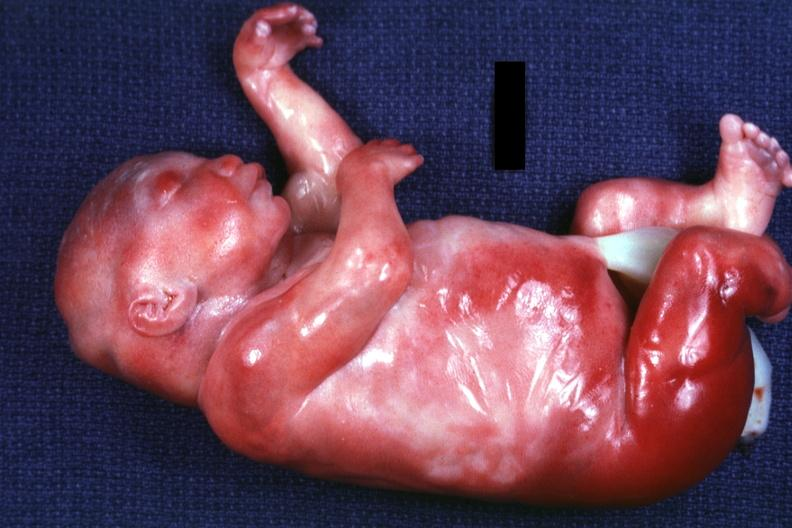what does lateral view of body with renal facies no neck and a barely seen vascular mass extruding from occipital region of skull arms and legs appear too short have?
Answer the question using a single word or phrase. Six digits 